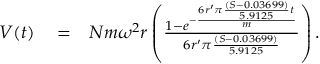<formula> <loc_0><loc_0><loc_500><loc_500>\begin{array} { r l r } { V ( t ) } & = } & { N m \omega ^ { 2 } r \left ( { \frac { 1 - e ^ { - { \frac { 6 r ^ { \prime } \pi { \frac { ( S - 0 . 0 3 6 9 9 ) } { 5 . 9 1 2 5 } } t } { m } } } } { 6 r ^ { \prime } \pi { \frac { ( S - 0 . 0 3 6 9 9 ) } { 5 . 9 1 2 5 } } } } \right ) . } \end{array}</formula> 